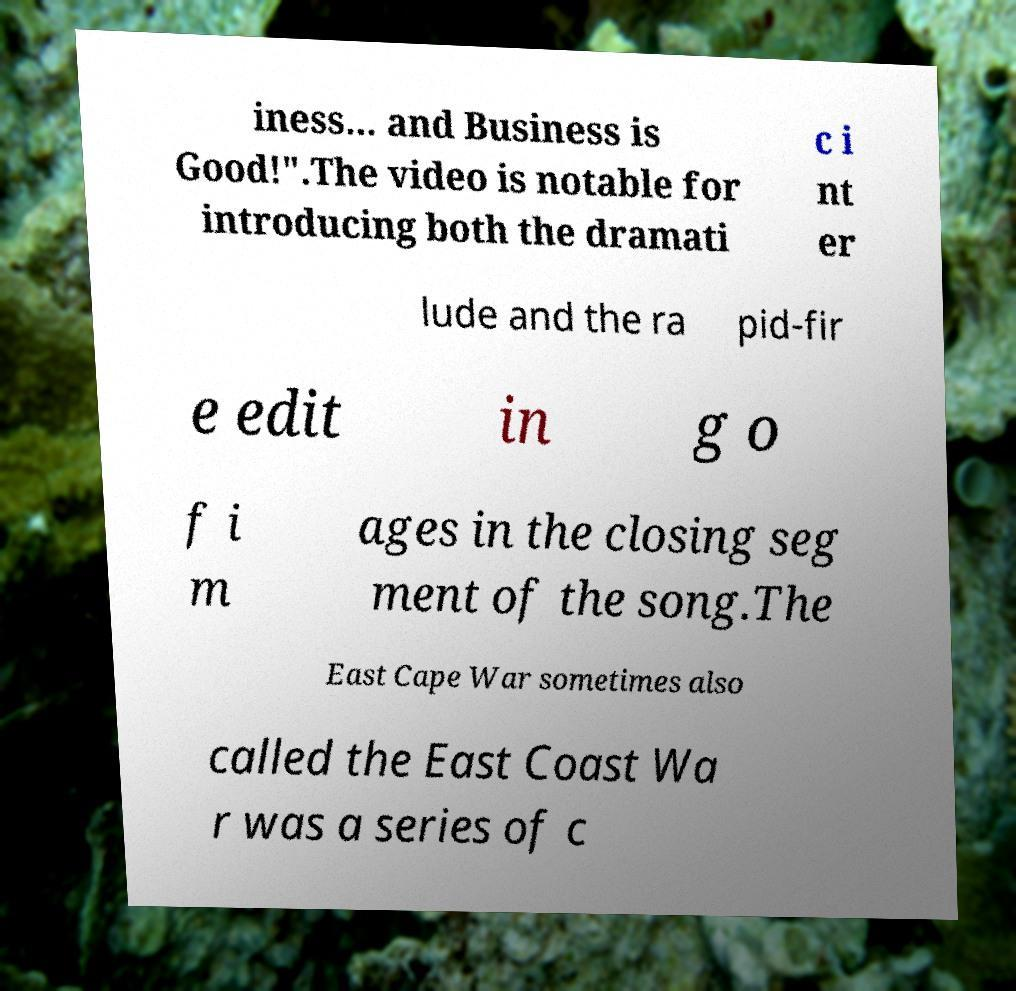Please identify and transcribe the text found in this image. iness... and Business is Good!".The video is notable for introducing both the dramati c i nt er lude and the ra pid-fir e edit in g o f i m ages in the closing seg ment of the song.The East Cape War sometimes also called the East Coast Wa r was a series of c 